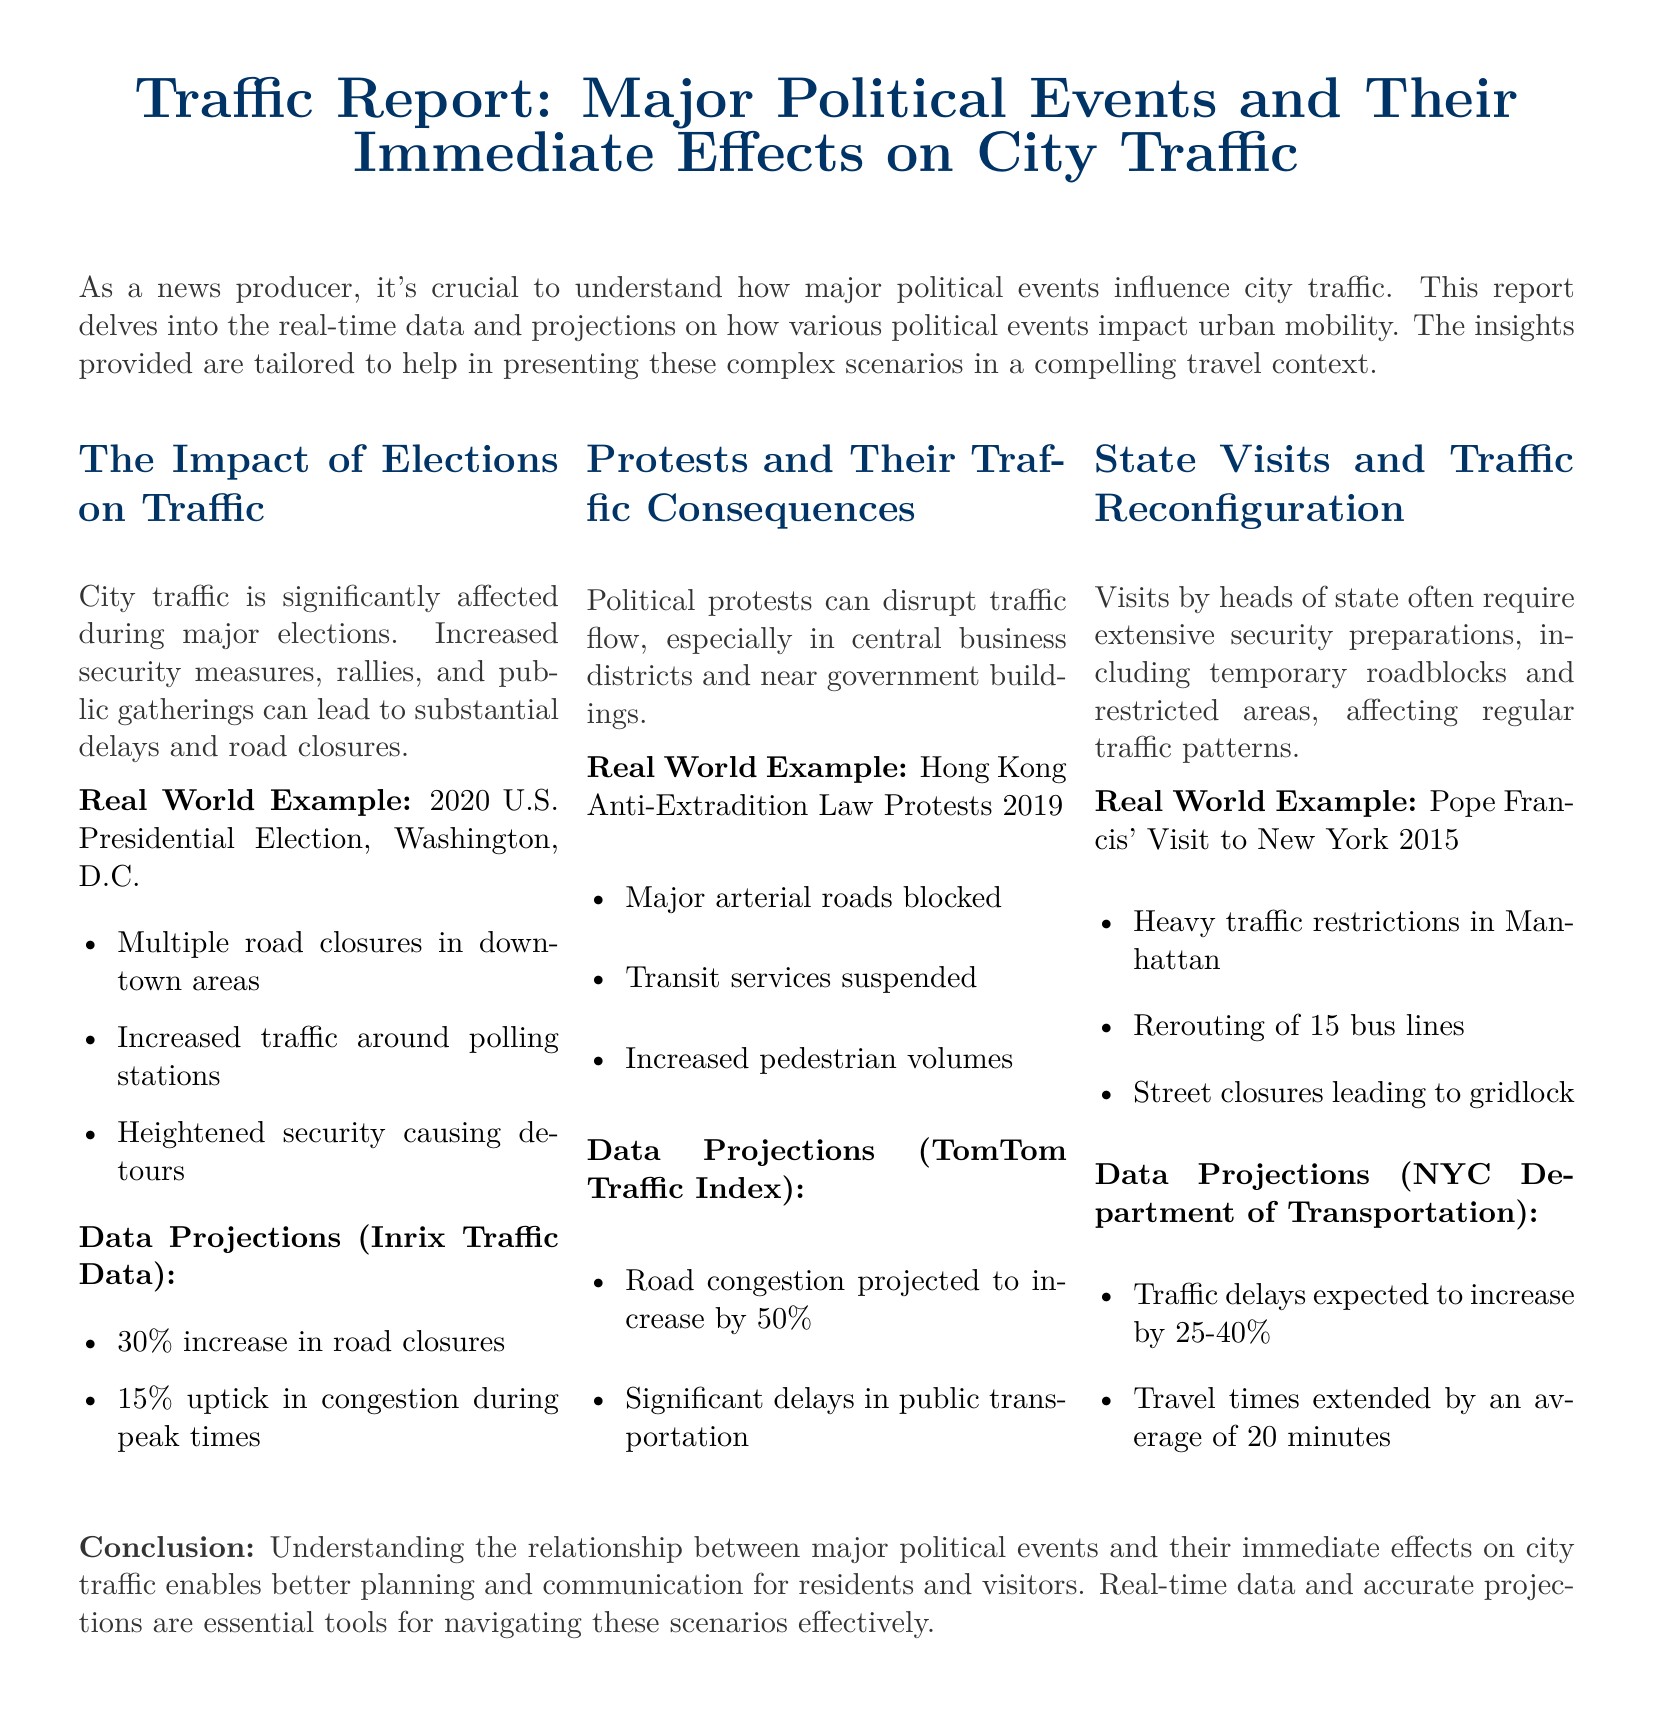What is the example of a major election mentioned in the report? The report cites the 2020 U.S. Presidential Election in Washington, D.C. as an example of a major election impacting traffic.
Answer: 2020 U.S. Presidential Election What is the projected increase in road closures during major elections? According to the data projections, a 30% increase in road closures is expected during major elections.
Answer: 30% What was a major consequence of the Hong Kong protests in 2019? The protests led to major arterial roads being blocked, significantly disrupting traffic flow.
Answer: Major arterial roads blocked What is the expected percentage increase in road congestion during protests? The data projections indicate that road congestion is projected to increase by 50% during protests.
Answer: 50% How much extending of travel times is projected during state visits? The report anticipates that travel times could be extended by an average of 20 minutes during state visits.
Answer: 20 minutes What is one of the traffic reconfigurations caused by Pope Francis' visit? The visit resulted in heavy traffic restrictions in Manhattan, affecting normal traffic patterns.
Answer: Heavy traffic restrictions in Manhattan What is the expected increase in traffic delays during state visits? The report states that traffic delays are expected to increase by 25-40% during state visits.
Answer: 25-40% Which department provided projections on traffic for state visits? The NYC Department of Transportation provided the data projections regarding traffic delays during state visits.
Answer: NYC Department of Transportation 